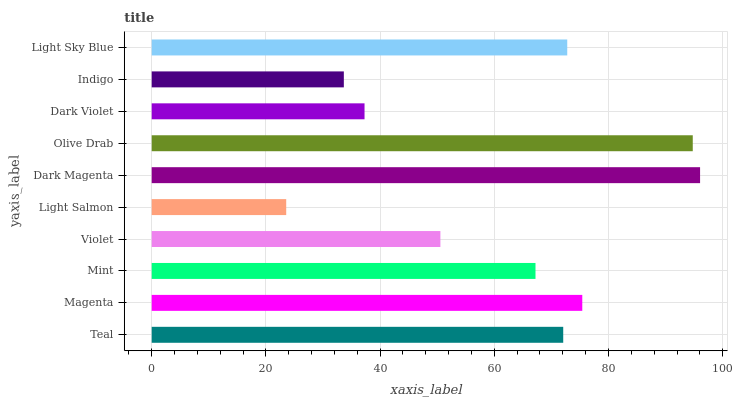Is Light Salmon the minimum?
Answer yes or no. Yes. Is Dark Magenta the maximum?
Answer yes or no. Yes. Is Magenta the minimum?
Answer yes or no. No. Is Magenta the maximum?
Answer yes or no. No. Is Magenta greater than Teal?
Answer yes or no. Yes. Is Teal less than Magenta?
Answer yes or no. Yes. Is Teal greater than Magenta?
Answer yes or no. No. Is Magenta less than Teal?
Answer yes or no. No. Is Teal the high median?
Answer yes or no. Yes. Is Mint the low median?
Answer yes or no. Yes. Is Light Sky Blue the high median?
Answer yes or no. No. Is Teal the low median?
Answer yes or no. No. 